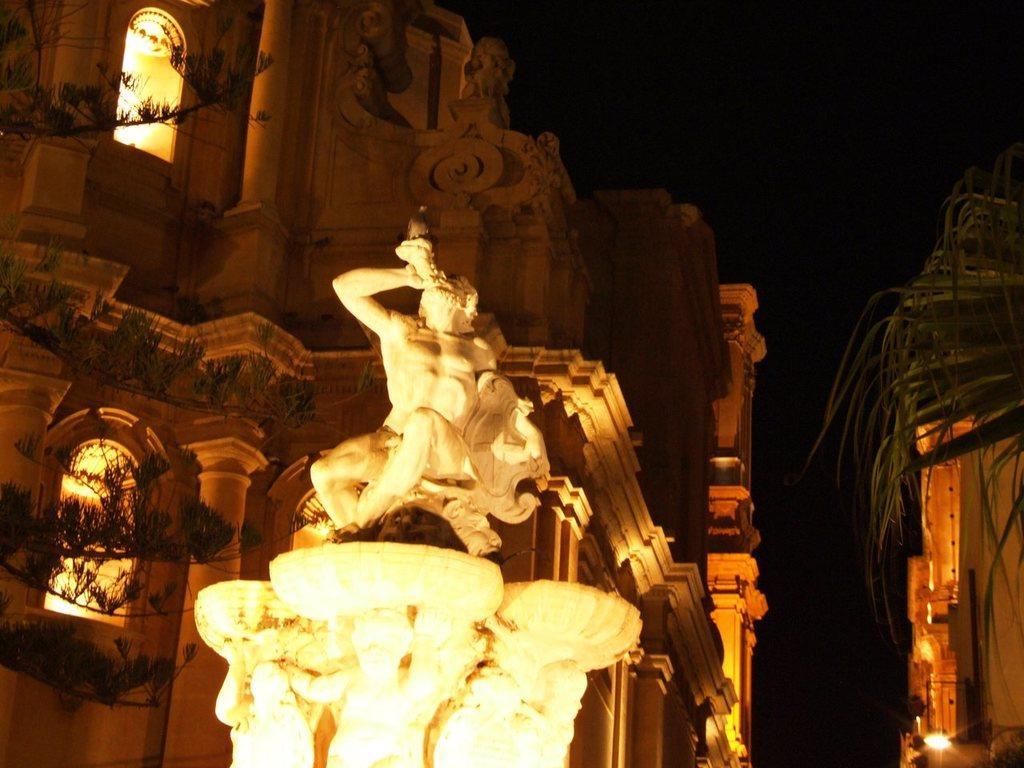Could you give a brief overview of what you see in this image? In this image in the foreground there is a sculpture, and in the background there are buildings, plants and we could see some lights. 